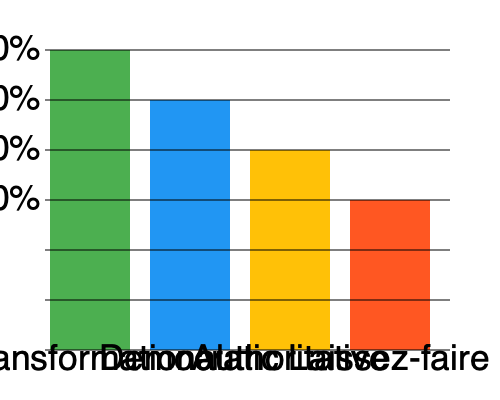Based on the bar graph showing the most common leadership styles among Fortune 500 CEOs, which style is most prevalent and what percentage of CEOs adopt this approach? To answer this question, we need to analyze the bar graph carefully:

1. The graph shows four leadership styles: Transformational, Democratic, Authoritative, and Laissez-faire.

2. Each bar represents the percentage of Fortune 500 CEOs who adopt that particular leadership style.

3. The y-axis shows percentages from 0% to 40% in 10% increments.

4. Looking at the heights of the bars:
   - Transformational: Reaches the 40% mark
   - Democratic: Reaches the 30% mark
   - Authoritative: Reaches the 20% mark
   - Laissez-faire: Reaches the 15% mark (halfway between 10% and 20%)

5. The tallest bar corresponds to the Transformational leadership style, reaching 40%.

Therefore, the most prevalent leadership style among Fortune 500 CEOs is Transformational, adopted by 40% of the CEOs.
Answer: Transformational, 40% 